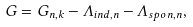Convert formula to latex. <formula><loc_0><loc_0><loc_500><loc_500>G = G _ { n , k } - \Lambda _ { i n d , n } - \Lambda _ { s p o n , n } ,</formula> 